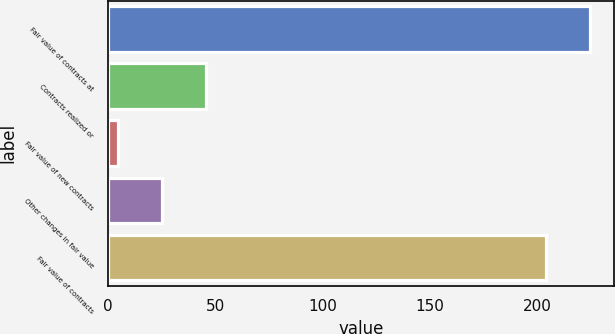Convert chart to OTSL. <chart><loc_0><loc_0><loc_500><loc_500><bar_chart><fcel>Fair value of contracts at<fcel>Contracts realized or<fcel>Fair value of new contracts<fcel>Other changes in fair value<fcel>Fair value of contracts<nl><fcel>224.4<fcel>45.8<fcel>5<fcel>25.4<fcel>204<nl></chart> 